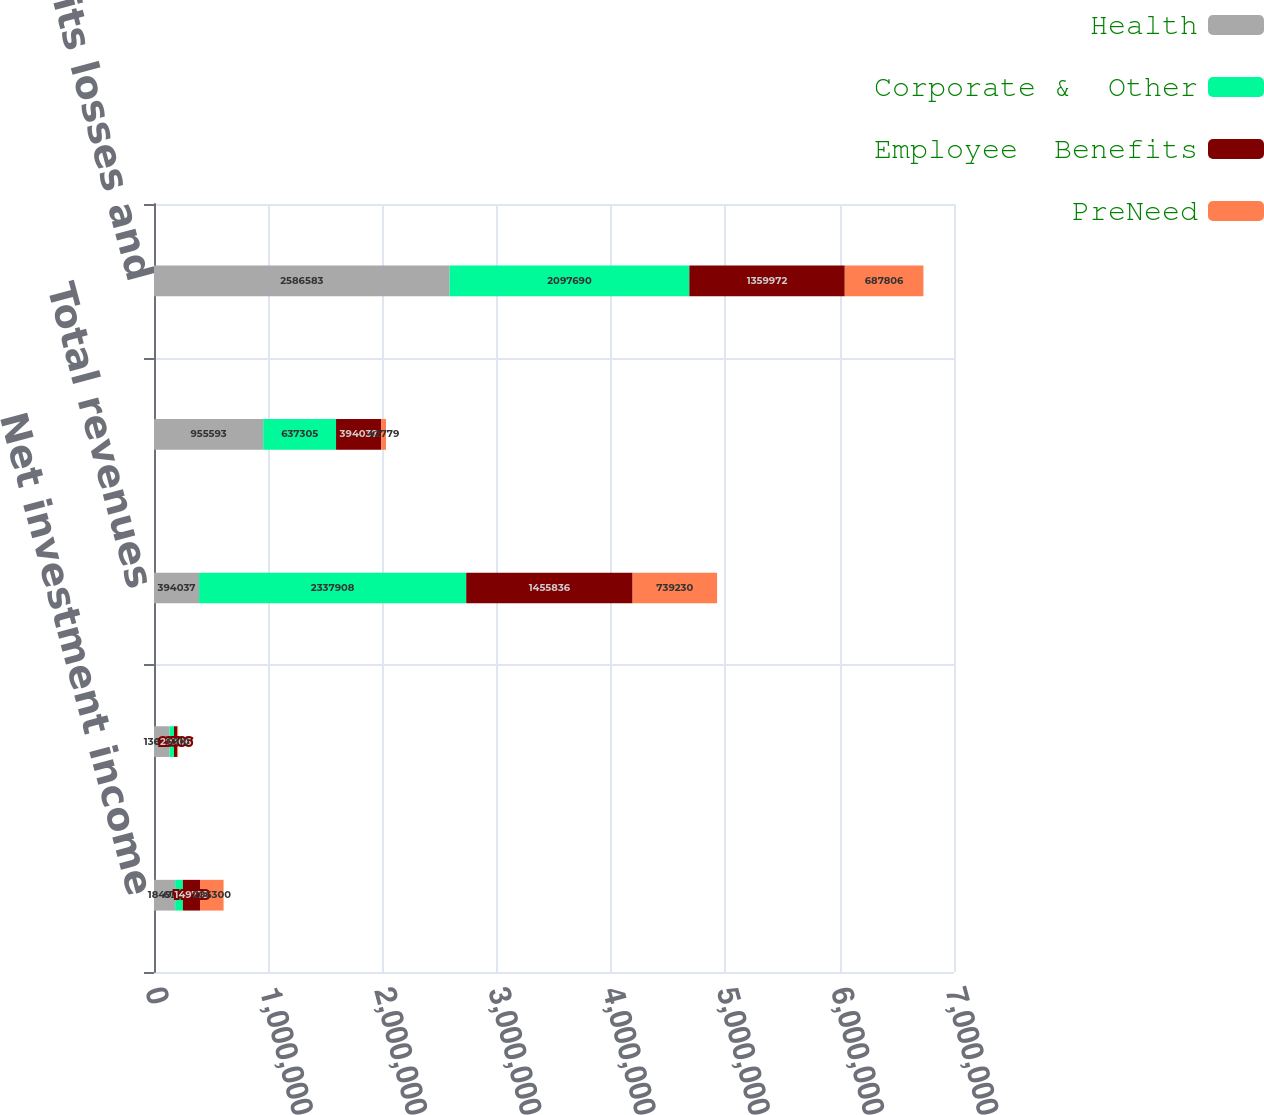Convert chart to OTSL. <chart><loc_0><loc_0><loc_500><loc_500><stacked_bar_chart><ecel><fcel>Net investment income<fcel>Fees and other income<fcel>Total revenues<fcel>Underwriting general and<fcel>Total benefits losses and<nl><fcel>Health<fcel>184951<fcel>136468<fcel>394037<fcel>955593<fcel>2.58658e+06<nl><fcel>Corporate &  Other<fcel>67902<fcel>38708<fcel>2.33791e+06<fcel>637305<fcel>2.09769e+06<nl><fcel>Employee  Benefits<fcel>149718<fcel>29306<fcel>1.45584e+06<fcel>394037<fcel>1.35997e+06<nl><fcel>PreNeed<fcel>206300<fcel>6810<fcel>739230<fcel>42779<fcel>687806<nl></chart> 